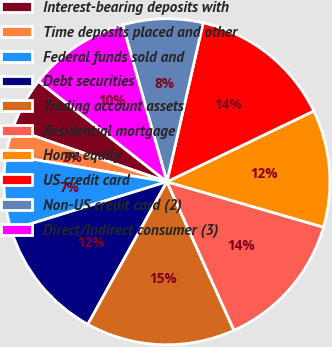<chart> <loc_0><loc_0><loc_500><loc_500><pie_chart><fcel>Interest-bearing deposits with<fcel>Time deposits placed and other<fcel>Federal funds sold and<fcel>Debt securities<fcel>Trading account assets<fcel>Residential mortgage<fcel>Home equity<fcel>US credit card<fcel>Non-US credit card (2)<fcel>Direct/Indirect consumer (3)<nl><fcel>5.29%<fcel>2.65%<fcel>7.41%<fcel>12.17%<fcel>14.81%<fcel>13.76%<fcel>11.64%<fcel>14.29%<fcel>7.94%<fcel>10.05%<nl></chart> 